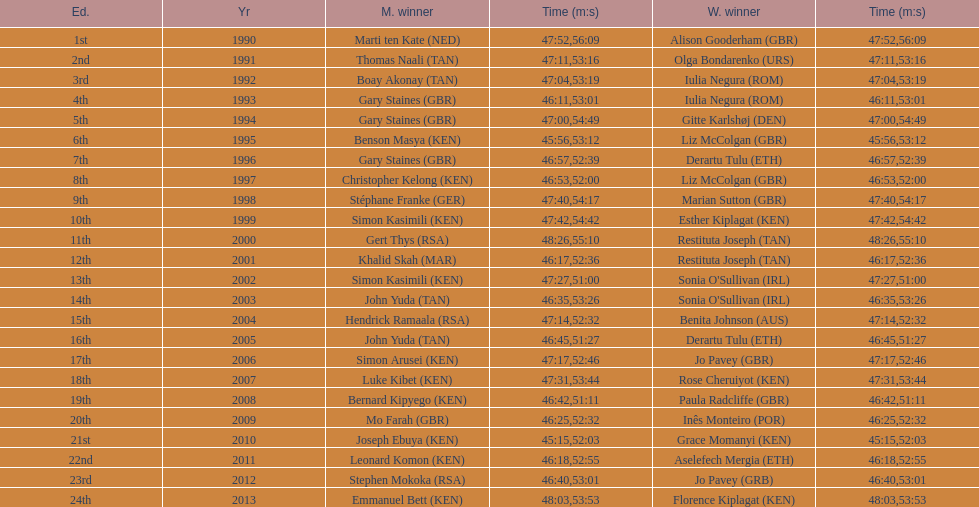What is the disparity in completion times between the men's and women's bupa great south run in 2013? 5:50. 